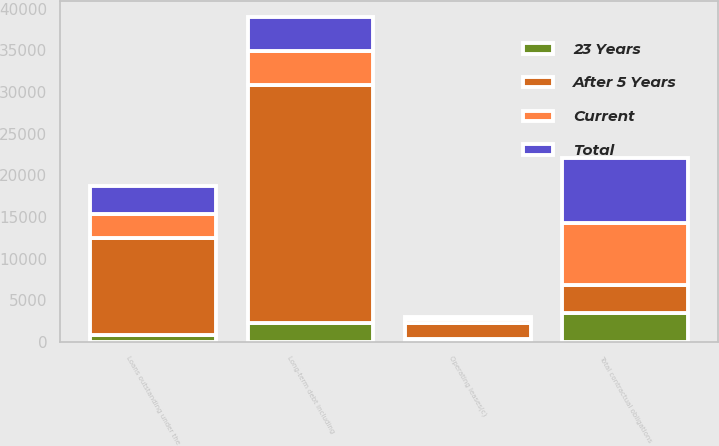<chart> <loc_0><loc_0><loc_500><loc_500><stacked_bar_chart><ecel><fcel>Long-term debt including<fcel>Loans outstanding under the<fcel>Operating leases(c)<fcel>Total contractual obligations<nl><fcel>After 5 Years<fcel>28545<fcel>11560<fcel>1934<fcel>3384<nl><fcel>23 Years<fcel>2248<fcel>860<fcel>280<fcel>3407<nl><fcel>Current<fcel>4089<fcel>2931<fcel>482<fcel>7510<nl><fcel>Total<fcel>4063<fcel>3384<fcel>302<fcel>7749<nl></chart> 